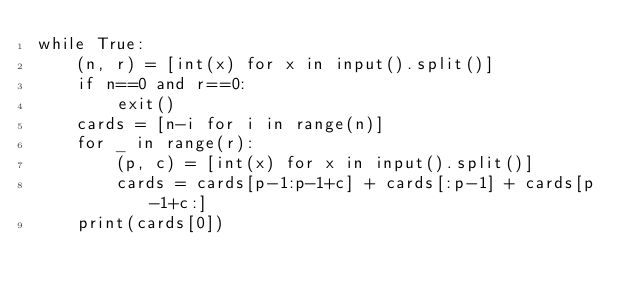Convert code to text. <code><loc_0><loc_0><loc_500><loc_500><_Python_>while True:
    (n, r) = [int(x) for x in input().split()]
    if n==0 and r==0:
        exit()
    cards = [n-i for i in range(n)]
    for _ in range(r):
        (p, c) = [int(x) for x in input().split()]
        cards = cards[p-1:p-1+c] + cards[:p-1] + cards[p-1+c:]
    print(cards[0])</code> 